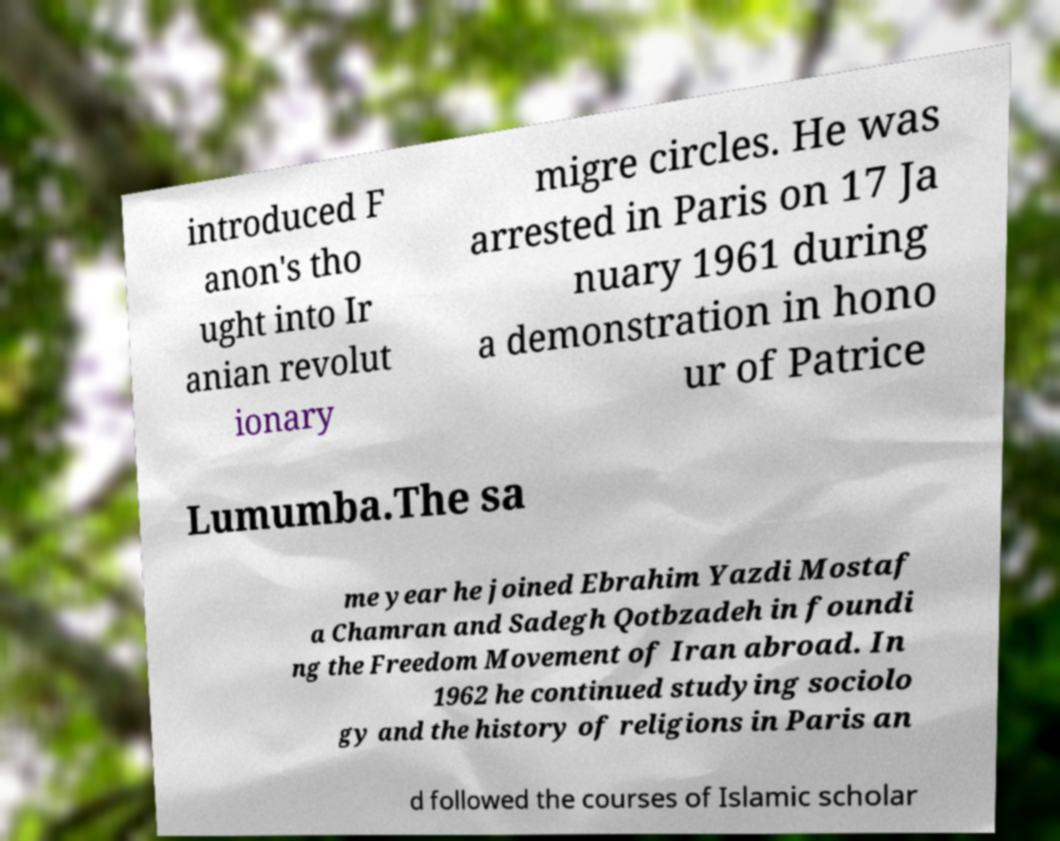Could you extract and type out the text from this image? introduced F anon's tho ught into Ir anian revolut ionary migre circles. He was arrested in Paris on 17 Ja nuary 1961 during a demonstration in hono ur of Patrice Lumumba.The sa me year he joined Ebrahim Yazdi Mostaf a Chamran and Sadegh Qotbzadeh in foundi ng the Freedom Movement of Iran abroad. In 1962 he continued studying sociolo gy and the history of religions in Paris an d followed the courses of Islamic scholar 